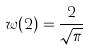Convert formula to latex. <formula><loc_0><loc_0><loc_500><loc_500>w ( 2 ) = \frac { 2 } { \sqrt { \pi } }</formula> 